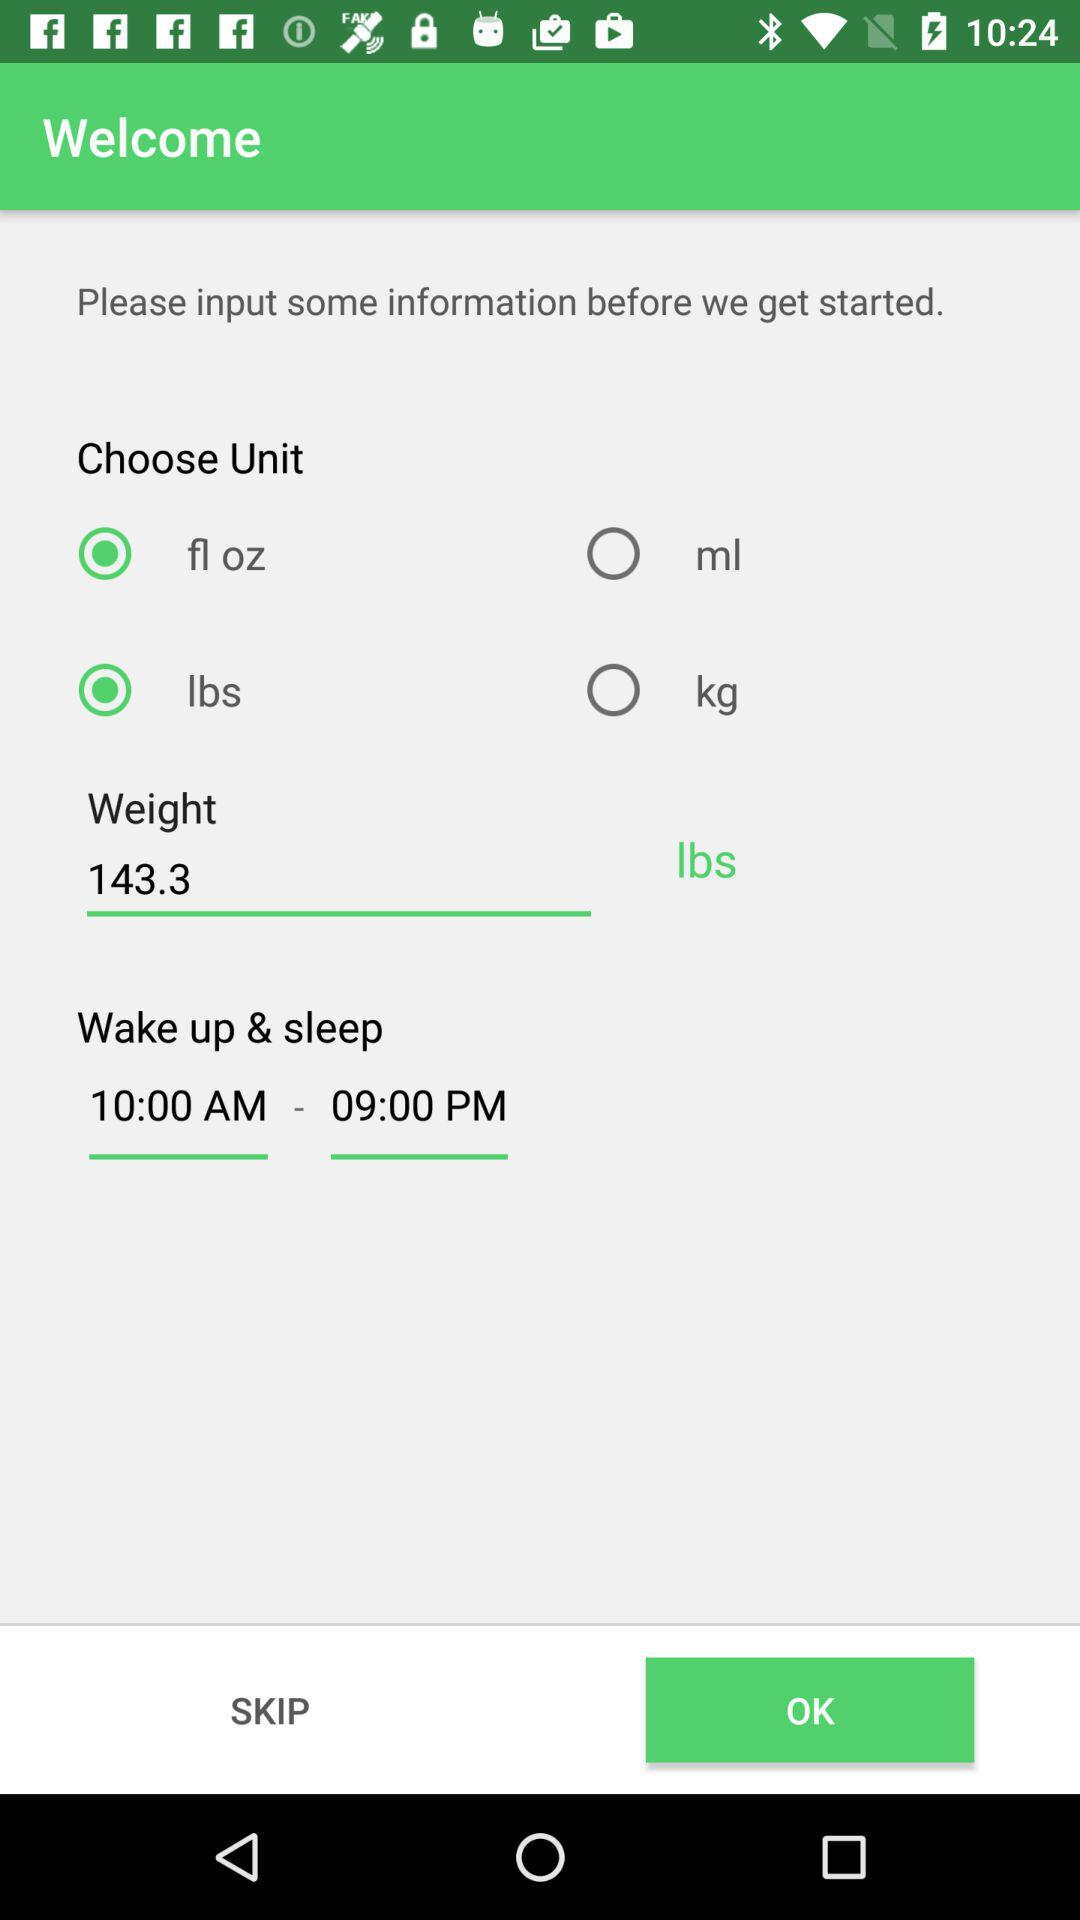Which are the selected units? The selected units are "fl oz" and "lbs". 